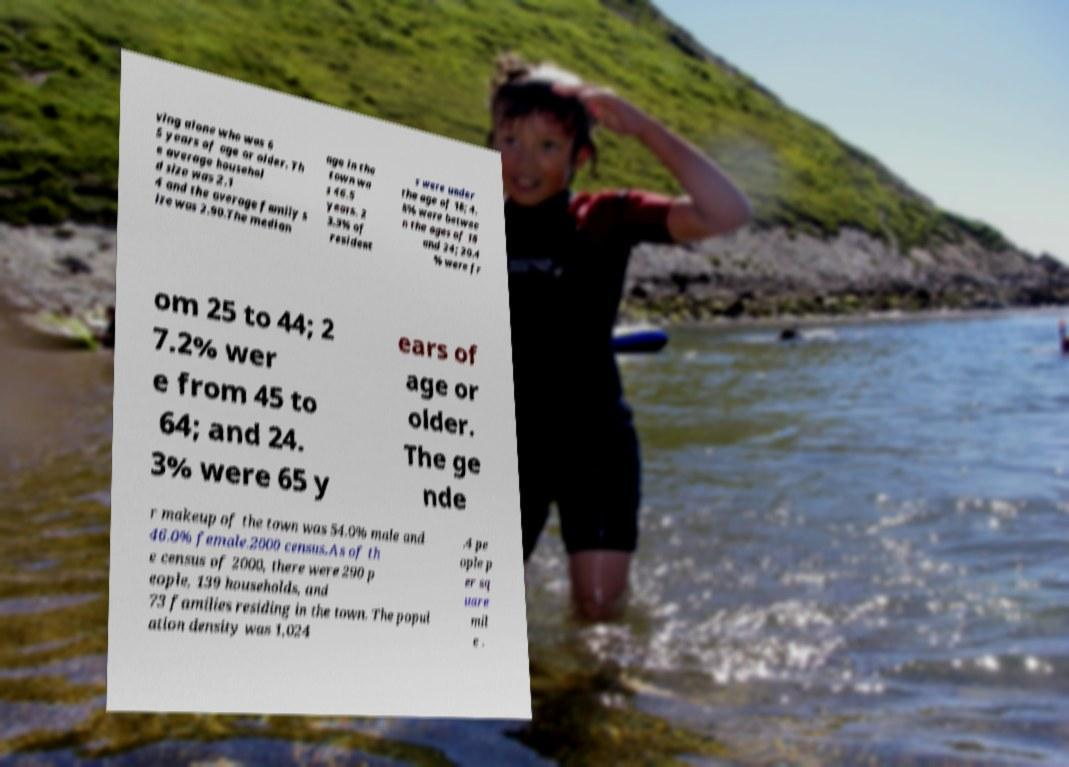Could you extract and type out the text from this image? ving alone who was 6 5 years of age or older. Th e average househol d size was 2.1 4 and the average family s ize was 2.90.The median age in the town wa s 46.5 years. 2 3.3% of resident s were under the age of 18; 4. 8% were betwee n the ages of 18 and 24; 20.4 % were fr om 25 to 44; 2 7.2% wer e from 45 to 64; and 24. 3% were 65 y ears of age or older. The ge nde r makeup of the town was 54.0% male and 46.0% female.2000 census.As of th e census of 2000, there were 290 p eople, 139 households, and 73 families residing in the town. The popul ation density was 1,024 .4 pe ople p er sq uare mil e . 